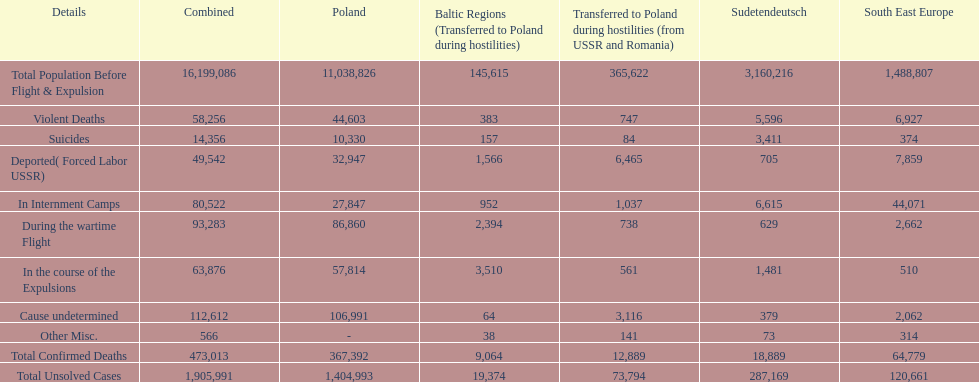How many causes were responsible for more than 50,000 confirmed deaths? 5. 